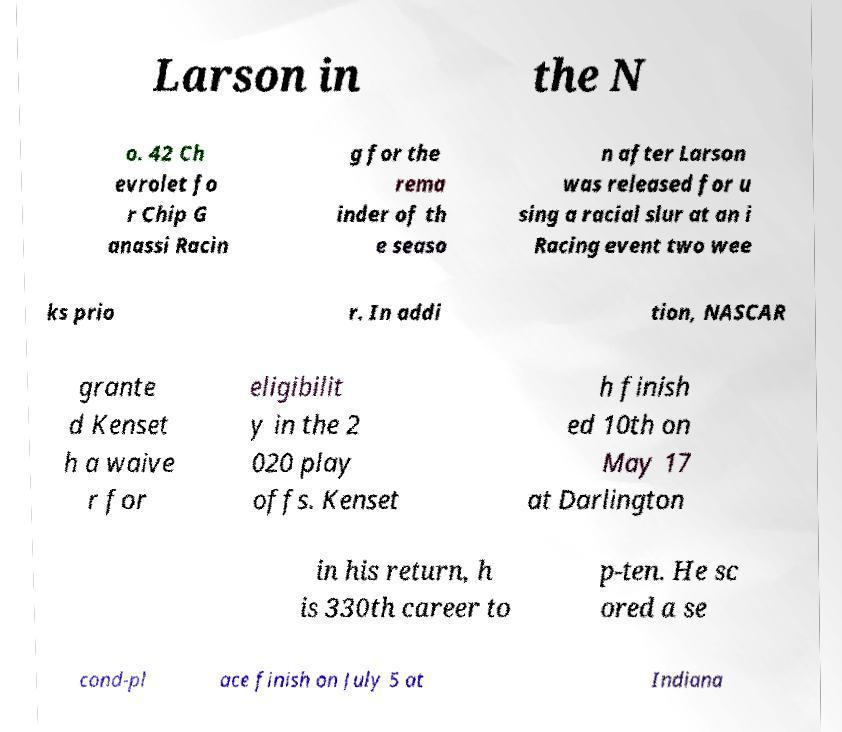Could you assist in decoding the text presented in this image and type it out clearly? Larson in the N o. 42 Ch evrolet fo r Chip G anassi Racin g for the rema inder of th e seaso n after Larson was released for u sing a racial slur at an i Racing event two wee ks prio r. In addi tion, NASCAR grante d Kenset h a waive r for eligibilit y in the 2 020 play offs. Kenset h finish ed 10th on May 17 at Darlington in his return, h is 330th career to p-ten. He sc ored a se cond-pl ace finish on July 5 at Indiana 